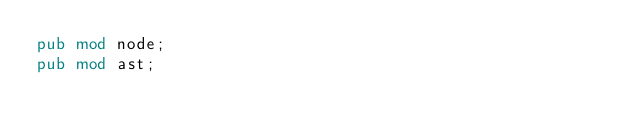<code> <loc_0><loc_0><loc_500><loc_500><_Rust_>pub mod node;
pub mod ast;

</code> 